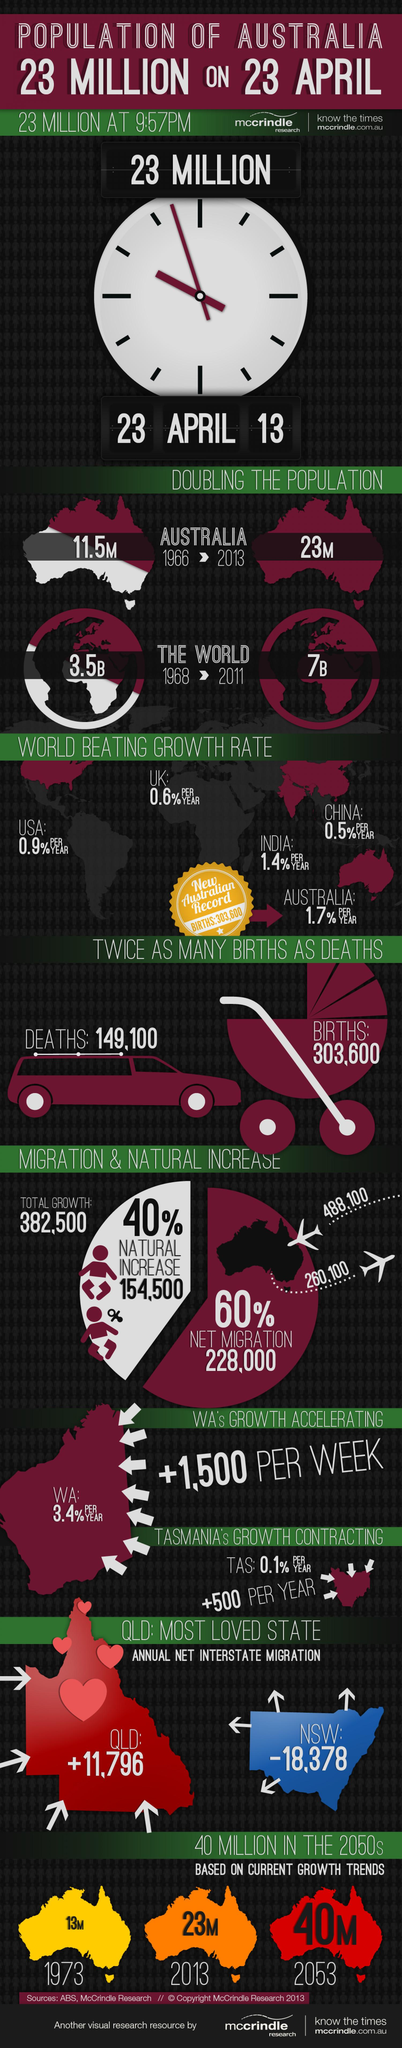Indicate a few pertinent items in this graphic. In 2013, the population was 17 million. In 2053, the population is expected to be 17 million. The population in 2053 is expected to be 27 million higher than the population in 1973. The population in 2013 was approximately 10 million more than the population in 1973. 